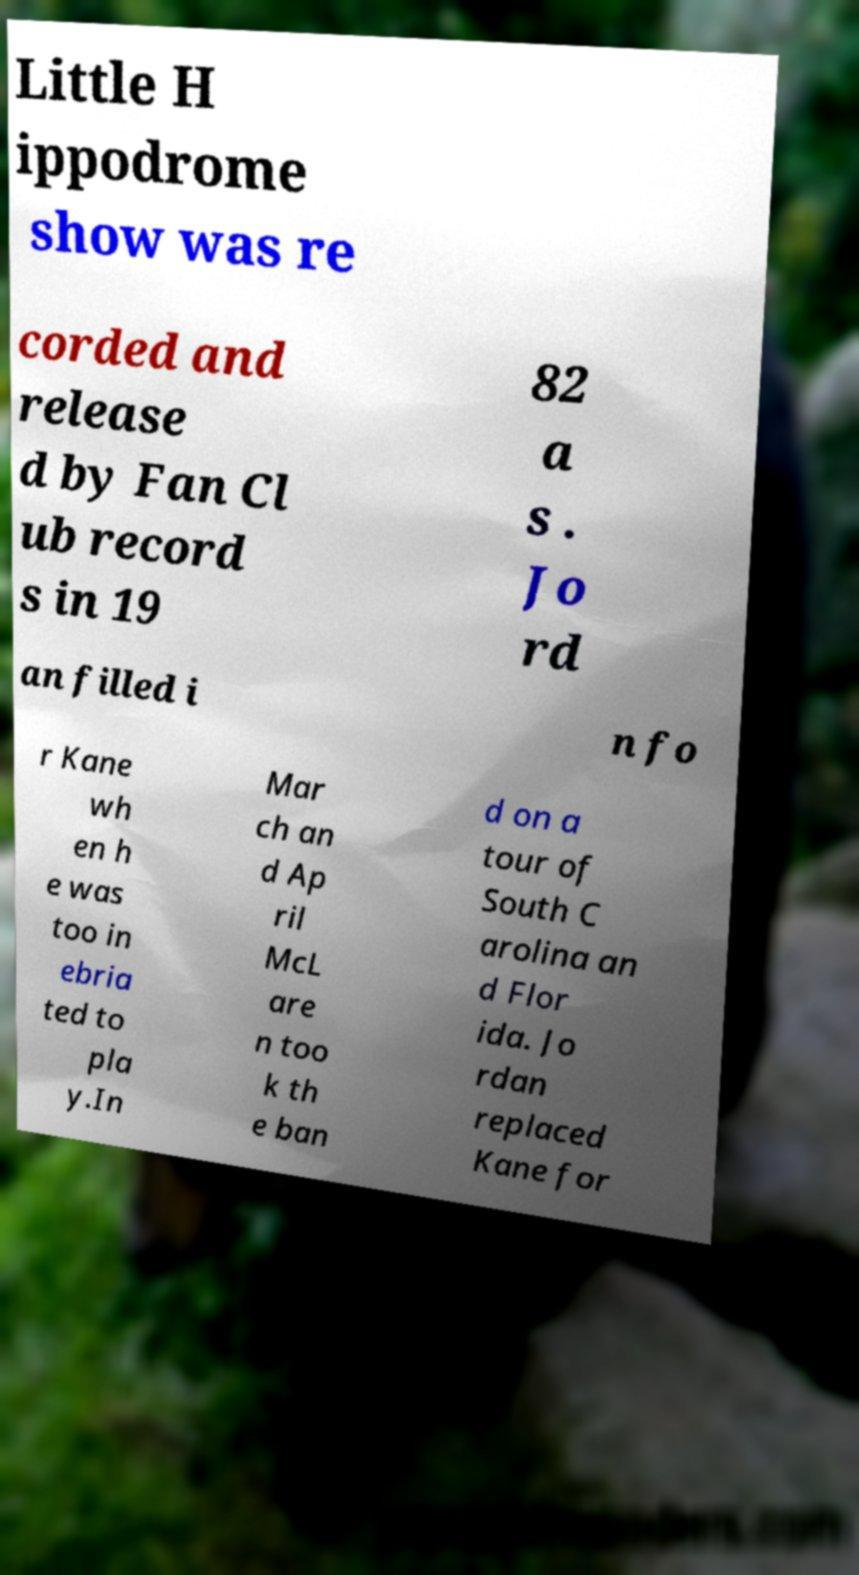Can you read and provide the text displayed in the image?This photo seems to have some interesting text. Can you extract and type it out for me? Little H ippodrome show was re corded and release d by Fan Cl ub record s in 19 82 a s . Jo rd an filled i n fo r Kane wh en h e was too in ebria ted to pla y.In Mar ch an d Ap ril McL are n too k th e ban d on a tour of South C arolina an d Flor ida. Jo rdan replaced Kane for 